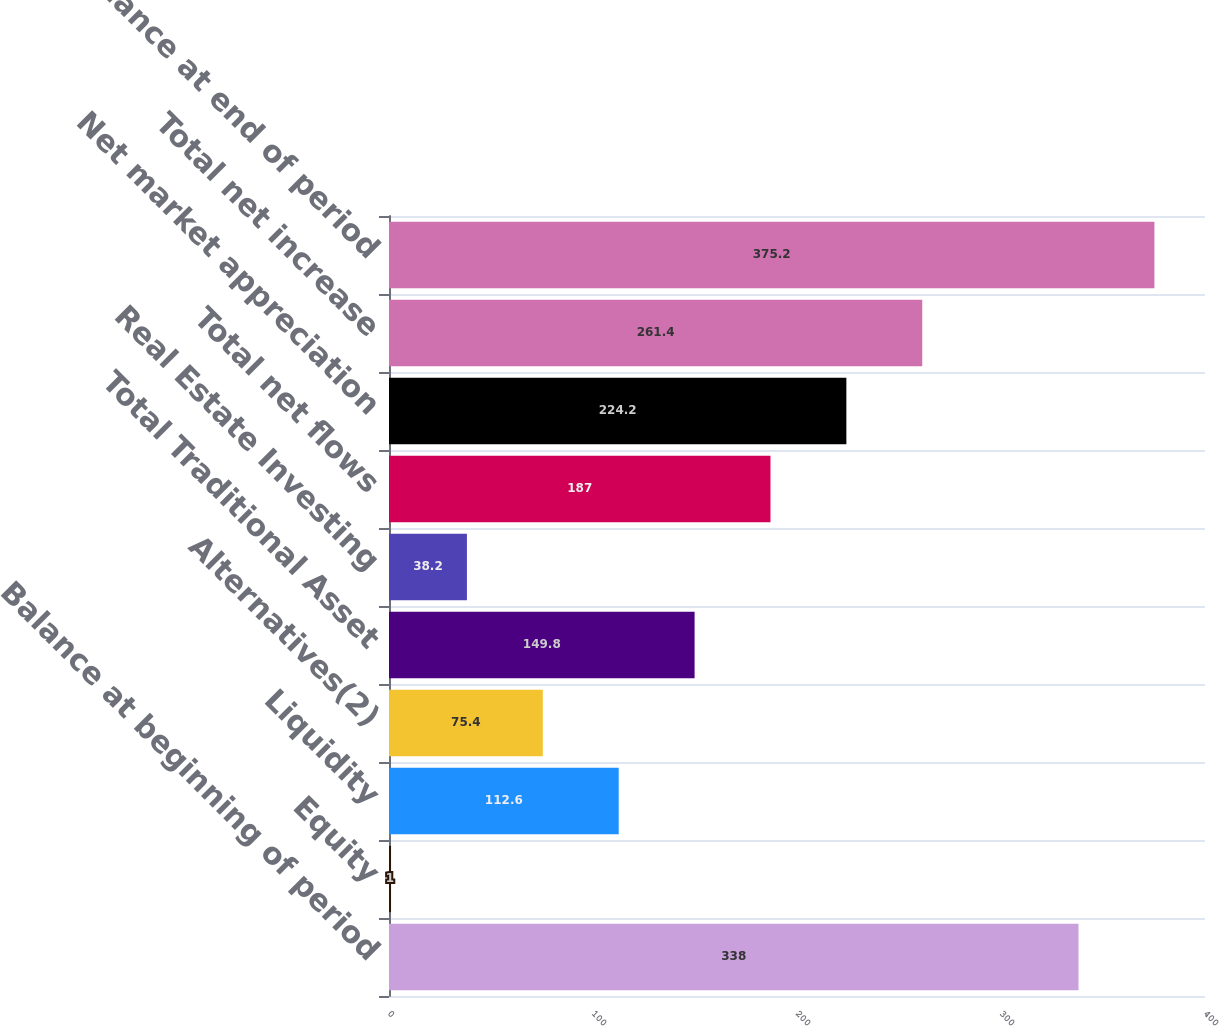Convert chart. <chart><loc_0><loc_0><loc_500><loc_500><bar_chart><fcel>Balance at beginning of period<fcel>Equity<fcel>Liquidity<fcel>Alternatives(2)<fcel>Total Traditional Asset<fcel>Real Estate Investing<fcel>Total net flows<fcel>Net market appreciation<fcel>Total net increase<fcel>Balance at end of period<nl><fcel>338<fcel>1<fcel>112.6<fcel>75.4<fcel>149.8<fcel>38.2<fcel>187<fcel>224.2<fcel>261.4<fcel>375.2<nl></chart> 